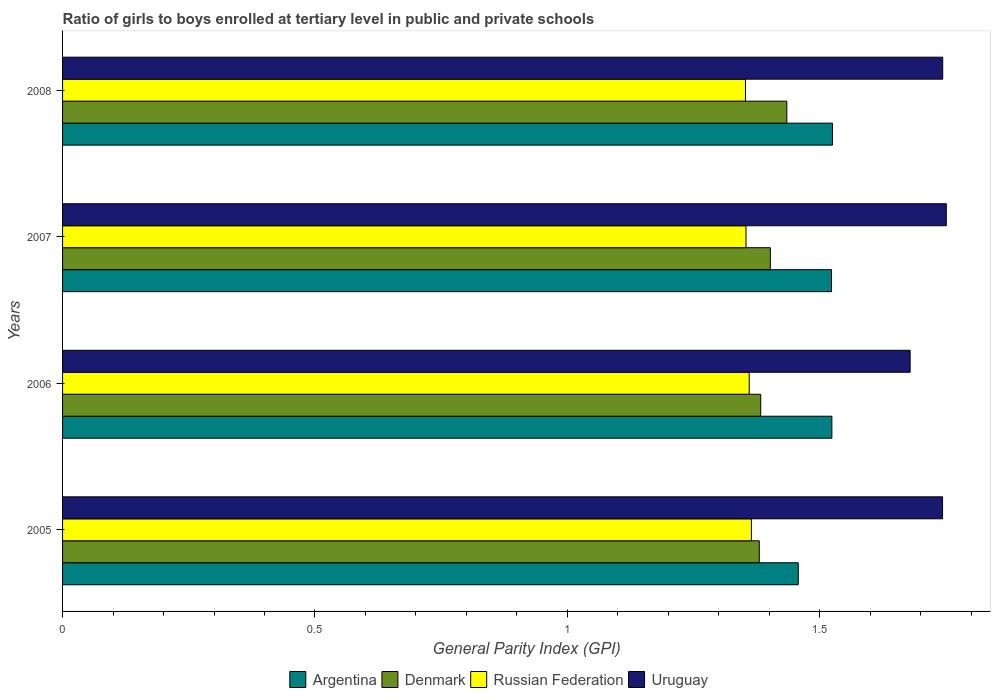How many different coloured bars are there?
Ensure brevity in your answer.  4. Are the number of bars per tick equal to the number of legend labels?
Your response must be concise. Yes. Are the number of bars on each tick of the Y-axis equal?
Offer a terse response. Yes. How many bars are there on the 4th tick from the top?
Your answer should be very brief. 4. How many bars are there on the 1st tick from the bottom?
Offer a terse response. 4. What is the general parity index in Uruguay in 2005?
Offer a very short reply. 1.74. Across all years, what is the maximum general parity index in Denmark?
Provide a succinct answer. 1.43. Across all years, what is the minimum general parity index in Denmark?
Offer a terse response. 1.38. In which year was the general parity index in Denmark minimum?
Provide a succinct answer. 2005. What is the total general parity index in Denmark in the graph?
Your answer should be very brief. 5.6. What is the difference between the general parity index in Argentina in 2007 and that in 2008?
Offer a very short reply. -0. What is the difference between the general parity index in Russian Federation in 2005 and the general parity index in Argentina in 2007?
Make the answer very short. -0.16. What is the average general parity index in Denmark per year?
Offer a terse response. 1.4. In the year 2008, what is the difference between the general parity index in Uruguay and general parity index in Denmark?
Give a very brief answer. 0.31. In how many years, is the general parity index in Denmark greater than 1.7 ?
Offer a very short reply. 0. What is the ratio of the general parity index in Denmark in 2005 to that in 2008?
Offer a terse response. 0.96. What is the difference between the highest and the second highest general parity index in Denmark?
Keep it short and to the point. 0.03. What is the difference between the highest and the lowest general parity index in Argentina?
Make the answer very short. 0.07. Is it the case that in every year, the sum of the general parity index in Argentina and general parity index in Uruguay is greater than the sum of general parity index in Denmark and general parity index in Russian Federation?
Ensure brevity in your answer.  Yes. What does the 1st bar from the bottom in 2006 represents?
Provide a short and direct response. Argentina. How many years are there in the graph?
Your answer should be compact. 4. What is the difference between two consecutive major ticks on the X-axis?
Offer a terse response. 0.5. Where does the legend appear in the graph?
Provide a short and direct response. Bottom center. How are the legend labels stacked?
Provide a succinct answer. Horizontal. What is the title of the graph?
Give a very brief answer. Ratio of girls to boys enrolled at tertiary level in public and private schools. What is the label or title of the X-axis?
Make the answer very short. General Parity Index (GPI). What is the General Parity Index (GPI) of Argentina in 2005?
Offer a very short reply. 1.46. What is the General Parity Index (GPI) of Denmark in 2005?
Ensure brevity in your answer.  1.38. What is the General Parity Index (GPI) in Russian Federation in 2005?
Offer a very short reply. 1.36. What is the General Parity Index (GPI) in Uruguay in 2005?
Your answer should be compact. 1.74. What is the General Parity Index (GPI) in Argentina in 2006?
Give a very brief answer. 1.52. What is the General Parity Index (GPI) in Denmark in 2006?
Offer a terse response. 1.38. What is the General Parity Index (GPI) in Russian Federation in 2006?
Give a very brief answer. 1.36. What is the General Parity Index (GPI) of Uruguay in 2006?
Make the answer very short. 1.68. What is the General Parity Index (GPI) in Argentina in 2007?
Give a very brief answer. 1.52. What is the General Parity Index (GPI) in Denmark in 2007?
Make the answer very short. 1.4. What is the General Parity Index (GPI) of Russian Federation in 2007?
Provide a short and direct response. 1.35. What is the General Parity Index (GPI) of Uruguay in 2007?
Offer a terse response. 1.75. What is the General Parity Index (GPI) in Argentina in 2008?
Ensure brevity in your answer.  1.53. What is the General Parity Index (GPI) of Denmark in 2008?
Your answer should be very brief. 1.43. What is the General Parity Index (GPI) of Russian Federation in 2008?
Give a very brief answer. 1.35. What is the General Parity Index (GPI) in Uruguay in 2008?
Provide a succinct answer. 1.74. Across all years, what is the maximum General Parity Index (GPI) in Argentina?
Ensure brevity in your answer.  1.53. Across all years, what is the maximum General Parity Index (GPI) of Denmark?
Provide a succinct answer. 1.43. Across all years, what is the maximum General Parity Index (GPI) in Russian Federation?
Give a very brief answer. 1.36. Across all years, what is the maximum General Parity Index (GPI) in Uruguay?
Give a very brief answer. 1.75. Across all years, what is the minimum General Parity Index (GPI) in Argentina?
Offer a terse response. 1.46. Across all years, what is the minimum General Parity Index (GPI) in Denmark?
Give a very brief answer. 1.38. Across all years, what is the minimum General Parity Index (GPI) in Russian Federation?
Provide a succinct answer. 1.35. Across all years, what is the minimum General Parity Index (GPI) of Uruguay?
Ensure brevity in your answer.  1.68. What is the total General Parity Index (GPI) in Argentina in the graph?
Your response must be concise. 6.03. What is the total General Parity Index (GPI) of Denmark in the graph?
Your answer should be compact. 5.6. What is the total General Parity Index (GPI) in Russian Federation in the graph?
Your answer should be very brief. 5.43. What is the total General Parity Index (GPI) in Uruguay in the graph?
Your response must be concise. 6.92. What is the difference between the General Parity Index (GPI) of Argentina in 2005 and that in 2006?
Your response must be concise. -0.07. What is the difference between the General Parity Index (GPI) of Denmark in 2005 and that in 2006?
Offer a very short reply. -0. What is the difference between the General Parity Index (GPI) of Russian Federation in 2005 and that in 2006?
Ensure brevity in your answer.  0. What is the difference between the General Parity Index (GPI) in Uruguay in 2005 and that in 2006?
Your answer should be very brief. 0.06. What is the difference between the General Parity Index (GPI) in Argentina in 2005 and that in 2007?
Offer a terse response. -0.07. What is the difference between the General Parity Index (GPI) in Denmark in 2005 and that in 2007?
Provide a succinct answer. -0.02. What is the difference between the General Parity Index (GPI) of Russian Federation in 2005 and that in 2007?
Your answer should be very brief. 0.01. What is the difference between the General Parity Index (GPI) in Uruguay in 2005 and that in 2007?
Your answer should be compact. -0.01. What is the difference between the General Parity Index (GPI) in Argentina in 2005 and that in 2008?
Your response must be concise. -0.07. What is the difference between the General Parity Index (GPI) of Denmark in 2005 and that in 2008?
Offer a terse response. -0.05. What is the difference between the General Parity Index (GPI) of Russian Federation in 2005 and that in 2008?
Your answer should be compact. 0.01. What is the difference between the General Parity Index (GPI) of Uruguay in 2005 and that in 2008?
Your answer should be very brief. -0. What is the difference between the General Parity Index (GPI) of Argentina in 2006 and that in 2007?
Offer a terse response. 0. What is the difference between the General Parity Index (GPI) of Denmark in 2006 and that in 2007?
Your answer should be compact. -0.02. What is the difference between the General Parity Index (GPI) in Russian Federation in 2006 and that in 2007?
Your answer should be very brief. 0.01. What is the difference between the General Parity Index (GPI) of Uruguay in 2006 and that in 2007?
Your answer should be very brief. -0.07. What is the difference between the General Parity Index (GPI) in Argentina in 2006 and that in 2008?
Offer a very short reply. -0. What is the difference between the General Parity Index (GPI) of Denmark in 2006 and that in 2008?
Provide a succinct answer. -0.05. What is the difference between the General Parity Index (GPI) in Russian Federation in 2006 and that in 2008?
Your answer should be very brief. 0.01. What is the difference between the General Parity Index (GPI) in Uruguay in 2006 and that in 2008?
Offer a very short reply. -0.06. What is the difference between the General Parity Index (GPI) in Argentina in 2007 and that in 2008?
Offer a terse response. -0. What is the difference between the General Parity Index (GPI) of Denmark in 2007 and that in 2008?
Your answer should be very brief. -0.03. What is the difference between the General Parity Index (GPI) of Russian Federation in 2007 and that in 2008?
Offer a terse response. 0. What is the difference between the General Parity Index (GPI) in Uruguay in 2007 and that in 2008?
Your answer should be compact. 0.01. What is the difference between the General Parity Index (GPI) of Argentina in 2005 and the General Parity Index (GPI) of Denmark in 2006?
Your answer should be very brief. 0.07. What is the difference between the General Parity Index (GPI) of Argentina in 2005 and the General Parity Index (GPI) of Russian Federation in 2006?
Make the answer very short. 0.1. What is the difference between the General Parity Index (GPI) in Argentina in 2005 and the General Parity Index (GPI) in Uruguay in 2006?
Provide a short and direct response. -0.22. What is the difference between the General Parity Index (GPI) of Denmark in 2005 and the General Parity Index (GPI) of Uruguay in 2006?
Offer a very short reply. -0.3. What is the difference between the General Parity Index (GPI) in Russian Federation in 2005 and the General Parity Index (GPI) in Uruguay in 2006?
Give a very brief answer. -0.31. What is the difference between the General Parity Index (GPI) in Argentina in 2005 and the General Parity Index (GPI) in Denmark in 2007?
Offer a terse response. 0.06. What is the difference between the General Parity Index (GPI) in Argentina in 2005 and the General Parity Index (GPI) in Russian Federation in 2007?
Keep it short and to the point. 0.1. What is the difference between the General Parity Index (GPI) in Argentina in 2005 and the General Parity Index (GPI) in Uruguay in 2007?
Keep it short and to the point. -0.29. What is the difference between the General Parity Index (GPI) of Denmark in 2005 and the General Parity Index (GPI) of Russian Federation in 2007?
Provide a succinct answer. 0.03. What is the difference between the General Parity Index (GPI) in Denmark in 2005 and the General Parity Index (GPI) in Uruguay in 2007?
Offer a terse response. -0.37. What is the difference between the General Parity Index (GPI) in Russian Federation in 2005 and the General Parity Index (GPI) in Uruguay in 2007?
Make the answer very short. -0.39. What is the difference between the General Parity Index (GPI) of Argentina in 2005 and the General Parity Index (GPI) of Denmark in 2008?
Offer a very short reply. 0.02. What is the difference between the General Parity Index (GPI) in Argentina in 2005 and the General Parity Index (GPI) in Russian Federation in 2008?
Offer a terse response. 0.1. What is the difference between the General Parity Index (GPI) in Argentina in 2005 and the General Parity Index (GPI) in Uruguay in 2008?
Provide a succinct answer. -0.29. What is the difference between the General Parity Index (GPI) of Denmark in 2005 and the General Parity Index (GPI) of Russian Federation in 2008?
Offer a terse response. 0.03. What is the difference between the General Parity Index (GPI) of Denmark in 2005 and the General Parity Index (GPI) of Uruguay in 2008?
Provide a succinct answer. -0.36. What is the difference between the General Parity Index (GPI) of Russian Federation in 2005 and the General Parity Index (GPI) of Uruguay in 2008?
Provide a short and direct response. -0.38. What is the difference between the General Parity Index (GPI) in Argentina in 2006 and the General Parity Index (GPI) in Denmark in 2007?
Make the answer very short. 0.12. What is the difference between the General Parity Index (GPI) of Argentina in 2006 and the General Parity Index (GPI) of Russian Federation in 2007?
Keep it short and to the point. 0.17. What is the difference between the General Parity Index (GPI) of Argentina in 2006 and the General Parity Index (GPI) of Uruguay in 2007?
Your answer should be very brief. -0.23. What is the difference between the General Parity Index (GPI) of Denmark in 2006 and the General Parity Index (GPI) of Russian Federation in 2007?
Keep it short and to the point. 0.03. What is the difference between the General Parity Index (GPI) of Denmark in 2006 and the General Parity Index (GPI) of Uruguay in 2007?
Offer a very short reply. -0.37. What is the difference between the General Parity Index (GPI) in Russian Federation in 2006 and the General Parity Index (GPI) in Uruguay in 2007?
Your response must be concise. -0.39. What is the difference between the General Parity Index (GPI) of Argentina in 2006 and the General Parity Index (GPI) of Denmark in 2008?
Offer a very short reply. 0.09. What is the difference between the General Parity Index (GPI) of Argentina in 2006 and the General Parity Index (GPI) of Russian Federation in 2008?
Provide a short and direct response. 0.17. What is the difference between the General Parity Index (GPI) in Argentina in 2006 and the General Parity Index (GPI) in Uruguay in 2008?
Offer a terse response. -0.22. What is the difference between the General Parity Index (GPI) of Denmark in 2006 and the General Parity Index (GPI) of Russian Federation in 2008?
Your answer should be compact. 0.03. What is the difference between the General Parity Index (GPI) of Denmark in 2006 and the General Parity Index (GPI) of Uruguay in 2008?
Give a very brief answer. -0.36. What is the difference between the General Parity Index (GPI) in Russian Federation in 2006 and the General Parity Index (GPI) in Uruguay in 2008?
Give a very brief answer. -0.38. What is the difference between the General Parity Index (GPI) of Argentina in 2007 and the General Parity Index (GPI) of Denmark in 2008?
Provide a short and direct response. 0.09. What is the difference between the General Parity Index (GPI) of Argentina in 2007 and the General Parity Index (GPI) of Russian Federation in 2008?
Provide a short and direct response. 0.17. What is the difference between the General Parity Index (GPI) of Argentina in 2007 and the General Parity Index (GPI) of Uruguay in 2008?
Give a very brief answer. -0.22. What is the difference between the General Parity Index (GPI) of Denmark in 2007 and the General Parity Index (GPI) of Russian Federation in 2008?
Provide a short and direct response. 0.05. What is the difference between the General Parity Index (GPI) in Denmark in 2007 and the General Parity Index (GPI) in Uruguay in 2008?
Give a very brief answer. -0.34. What is the difference between the General Parity Index (GPI) of Russian Federation in 2007 and the General Parity Index (GPI) of Uruguay in 2008?
Give a very brief answer. -0.39. What is the average General Parity Index (GPI) of Argentina per year?
Your answer should be compact. 1.51. What is the average General Parity Index (GPI) in Denmark per year?
Your answer should be very brief. 1.4. What is the average General Parity Index (GPI) in Russian Federation per year?
Give a very brief answer. 1.36. What is the average General Parity Index (GPI) of Uruguay per year?
Ensure brevity in your answer.  1.73. In the year 2005, what is the difference between the General Parity Index (GPI) in Argentina and General Parity Index (GPI) in Denmark?
Keep it short and to the point. 0.08. In the year 2005, what is the difference between the General Parity Index (GPI) of Argentina and General Parity Index (GPI) of Russian Federation?
Offer a terse response. 0.09. In the year 2005, what is the difference between the General Parity Index (GPI) of Argentina and General Parity Index (GPI) of Uruguay?
Make the answer very short. -0.29. In the year 2005, what is the difference between the General Parity Index (GPI) of Denmark and General Parity Index (GPI) of Russian Federation?
Offer a very short reply. 0.02. In the year 2005, what is the difference between the General Parity Index (GPI) of Denmark and General Parity Index (GPI) of Uruguay?
Your response must be concise. -0.36. In the year 2005, what is the difference between the General Parity Index (GPI) of Russian Federation and General Parity Index (GPI) of Uruguay?
Ensure brevity in your answer.  -0.38. In the year 2006, what is the difference between the General Parity Index (GPI) in Argentina and General Parity Index (GPI) in Denmark?
Your response must be concise. 0.14. In the year 2006, what is the difference between the General Parity Index (GPI) in Argentina and General Parity Index (GPI) in Russian Federation?
Your answer should be compact. 0.16. In the year 2006, what is the difference between the General Parity Index (GPI) in Argentina and General Parity Index (GPI) in Uruguay?
Provide a succinct answer. -0.16. In the year 2006, what is the difference between the General Parity Index (GPI) in Denmark and General Parity Index (GPI) in Russian Federation?
Your response must be concise. 0.02. In the year 2006, what is the difference between the General Parity Index (GPI) in Denmark and General Parity Index (GPI) in Uruguay?
Offer a very short reply. -0.3. In the year 2006, what is the difference between the General Parity Index (GPI) in Russian Federation and General Parity Index (GPI) in Uruguay?
Provide a succinct answer. -0.32. In the year 2007, what is the difference between the General Parity Index (GPI) of Argentina and General Parity Index (GPI) of Denmark?
Offer a terse response. 0.12. In the year 2007, what is the difference between the General Parity Index (GPI) in Argentina and General Parity Index (GPI) in Russian Federation?
Give a very brief answer. 0.17. In the year 2007, what is the difference between the General Parity Index (GPI) in Argentina and General Parity Index (GPI) in Uruguay?
Provide a short and direct response. -0.23. In the year 2007, what is the difference between the General Parity Index (GPI) of Denmark and General Parity Index (GPI) of Russian Federation?
Give a very brief answer. 0.05. In the year 2007, what is the difference between the General Parity Index (GPI) of Denmark and General Parity Index (GPI) of Uruguay?
Make the answer very short. -0.35. In the year 2007, what is the difference between the General Parity Index (GPI) in Russian Federation and General Parity Index (GPI) in Uruguay?
Your answer should be compact. -0.4. In the year 2008, what is the difference between the General Parity Index (GPI) in Argentina and General Parity Index (GPI) in Denmark?
Ensure brevity in your answer.  0.09. In the year 2008, what is the difference between the General Parity Index (GPI) of Argentina and General Parity Index (GPI) of Russian Federation?
Offer a very short reply. 0.17. In the year 2008, what is the difference between the General Parity Index (GPI) of Argentina and General Parity Index (GPI) of Uruguay?
Keep it short and to the point. -0.22. In the year 2008, what is the difference between the General Parity Index (GPI) of Denmark and General Parity Index (GPI) of Russian Federation?
Make the answer very short. 0.08. In the year 2008, what is the difference between the General Parity Index (GPI) of Denmark and General Parity Index (GPI) of Uruguay?
Your response must be concise. -0.31. In the year 2008, what is the difference between the General Parity Index (GPI) in Russian Federation and General Parity Index (GPI) in Uruguay?
Provide a short and direct response. -0.39. What is the ratio of the General Parity Index (GPI) in Argentina in 2005 to that in 2006?
Your response must be concise. 0.96. What is the ratio of the General Parity Index (GPI) of Russian Federation in 2005 to that in 2006?
Provide a short and direct response. 1. What is the ratio of the General Parity Index (GPI) in Uruguay in 2005 to that in 2006?
Ensure brevity in your answer.  1.04. What is the ratio of the General Parity Index (GPI) of Argentina in 2005 to that in 2007?
Your response must be concise. 0.96. What is the ratio of the General Parity Index (GPI) of Denmark in 2005 to that in 2007?
Provide a succinct answer. 0.98. What is the ratio of the General Parity Index (GPI) of Russian Federation in 2005 to that in 2007?
Your answer should be very brief. 1.01. What is the ratio of the General Parity Index (GPI) in Uruguay in 2005 to that in 2007?
Give a very brief answer. 1. What is the ratio of the General Parity Index (GPI) in Argentina in 2005 to that in 2008?
Provide a short and direct response. 0.96. What is the ratio of the General Parity Index (GPI) of Russian Federation in 2005 to that in 2008?
Ensure brevity in your answer.  1.01. What is the ratio of the General Parity Index (GPI) in Denmark in 2006 to that in 2007?
Provide a short and direct response. 0.99. What is the ratio of the General Parity Index (GPI) in Uruguay in 2006 to that in 2007?
Your answer should be compact. 0.96. What is the ratio of the General Parity Index (GPI) of Argentina in 2006 to that in 2008?
Give a very brief answer. 1. What is the ratio of the General Parity Index (GPI) in Russian Federation in 2006 to that in 2008?
Provide a short and direct response. 1.01. What is the ratio of the General Parity Index (GPI) of Uruguay in 2006 to that in 2008?
Ensure brevity in your answer.  0.96. What is the ratio of the General Parity Index (GPI) in Argentina in 2007 to that in 2008?
Provide a succinct answer. 1. What is the ratio of the General Parity Index (GPI) of Denmark in 2007 to that in 2008?
Your response must be concise. 0.98. What is the ratio of the General Parity Index (GPI) in Russian Federation in 2007 to that in 2008?
Provide a short and direct response. 1. What is the difference between the highest and the second highest General Parity Index (GPI) of Argentina?
Your response must be concise. 0. What is the difference between the highest and the second highest General Parity Index (GPI) of Denmark?
Make the answer very short. 0.03. What is the difference between the highest and the second highest General Parity Index (GPI) in Russian Federation?
Offer a terse response. 0. What is the difference between the highest and the second highest General Parity Index (GPI) in Uruguay?
Provide a short and direct response. 0.01. What is the difference between the highest and the lowest General Parity Index (GPI) in Argentina?
Offer a terse response. 0.07. What is the difference between the highest and the lowest General Parity Index (GPI) in Denmark?
Your answer should be compact. 0.05. What is the difference between the highest and the lowest General Parity Index (GPI) in Russian Federation?
Your response must be concise. 0.01. What is the difference between the highest and the lowest General Parity Index (GPI) of Uruguay?
Provide a short and direct response. 0.07. 